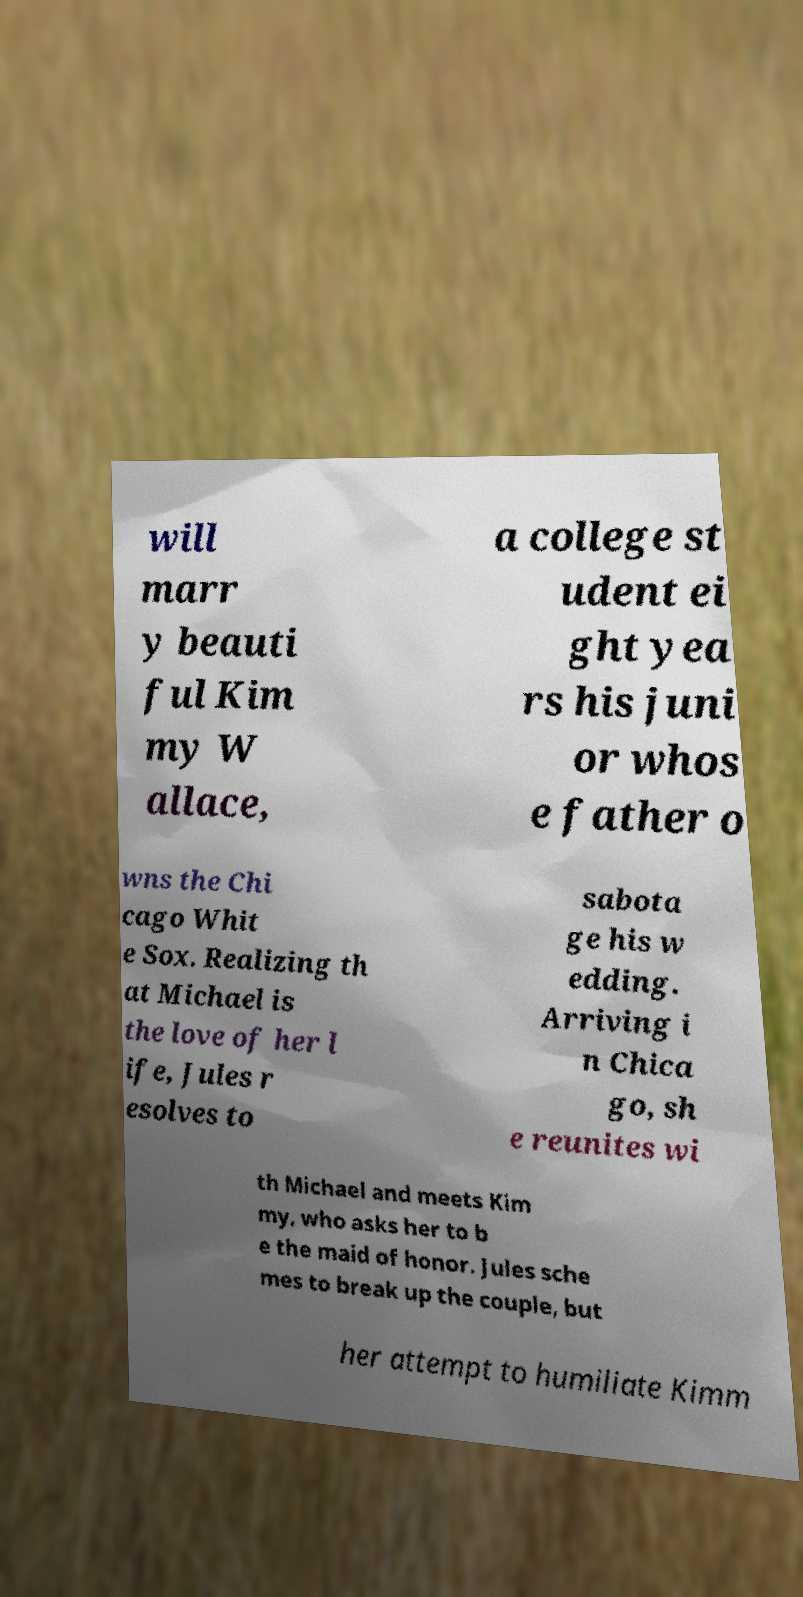Can you accurately transcribe the text from the provided image for me? will marr y beauti ful Kim my W allace, a college st udent ei ght yea rs his juni or whos e father o wns the Chi cago Whit e Sox. Realizing th at Michael is the love of her l ife, Jules r esolves to sabota ge his w edding. Arriving i n Chica go, sh e reunites wi th Michael and meets Kim my, who asks her to b e the maid of honor. Jules sche mes to break up the couple, but her attempt to humiliate Kimm 